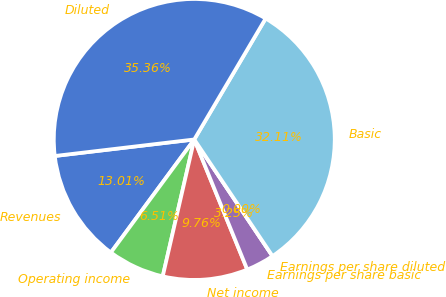Convert chart to OTSL. <chart><loc_0><loc_0><loc_500><loc_500><pie_chart><fcel>Revenues<fcel>Operating income<fcel>Net income<fcel>Earnings per share basic<fcel>Earnings per share diluted<fcel>Basic<fcel>Diluted<nl><fcel>13.01%<fcel>6.51%<fcel>9.76%<fcel>3.25%<fcel>0.0%<fcel>32.11%<fcel>35.36%<nl></chart> 